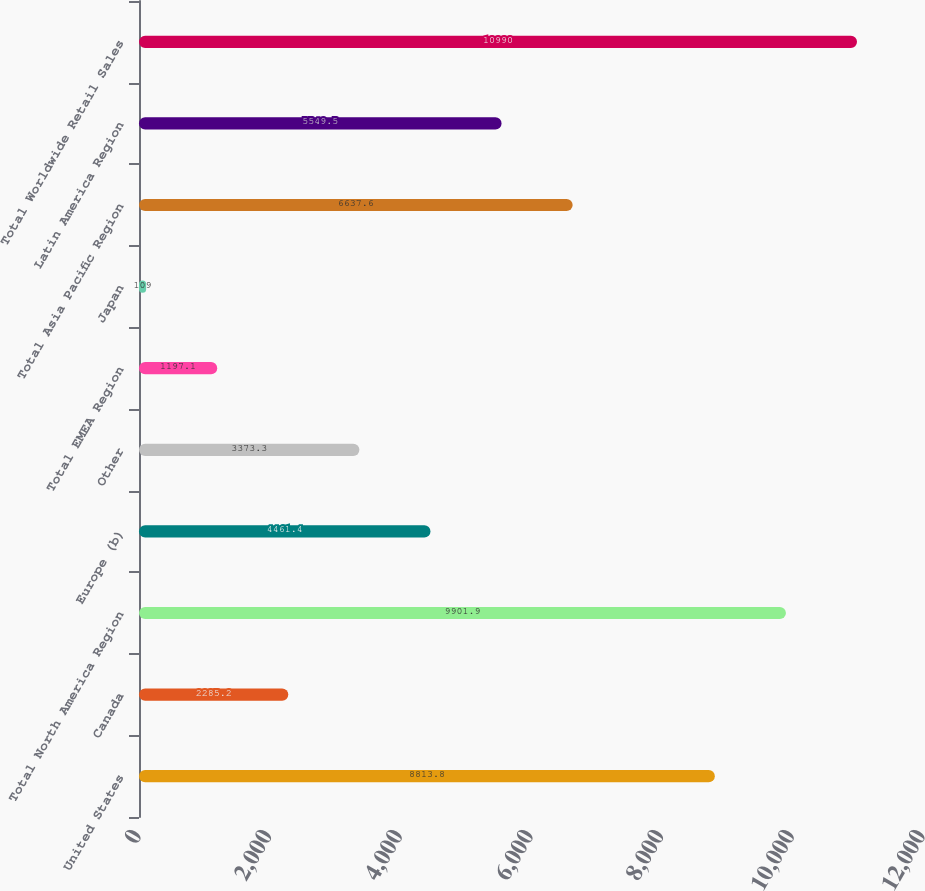Convert chart. <chart><loc_0><loc_0><loc_500><loc_500><bar_chart><fcel>United States<fcel>Canada<fcel>Total North America Region<fcel>Europe (b)<fcel>Other<fcel>Total EMEA Region<fcel>Japan<fcel>Total Asia Pacific Region<fcel>Latin America Region<fcel>Total Worldwide Retail Sales<nl><fcel>8813.8<fcel>2285.2<fcel>9901.9<fcel>4461.4<fcel>3373.3<fcel>1197.1<fcel>109<fcel>6637.6<fcel>5549.5<fcel>10990<nl></chart> 